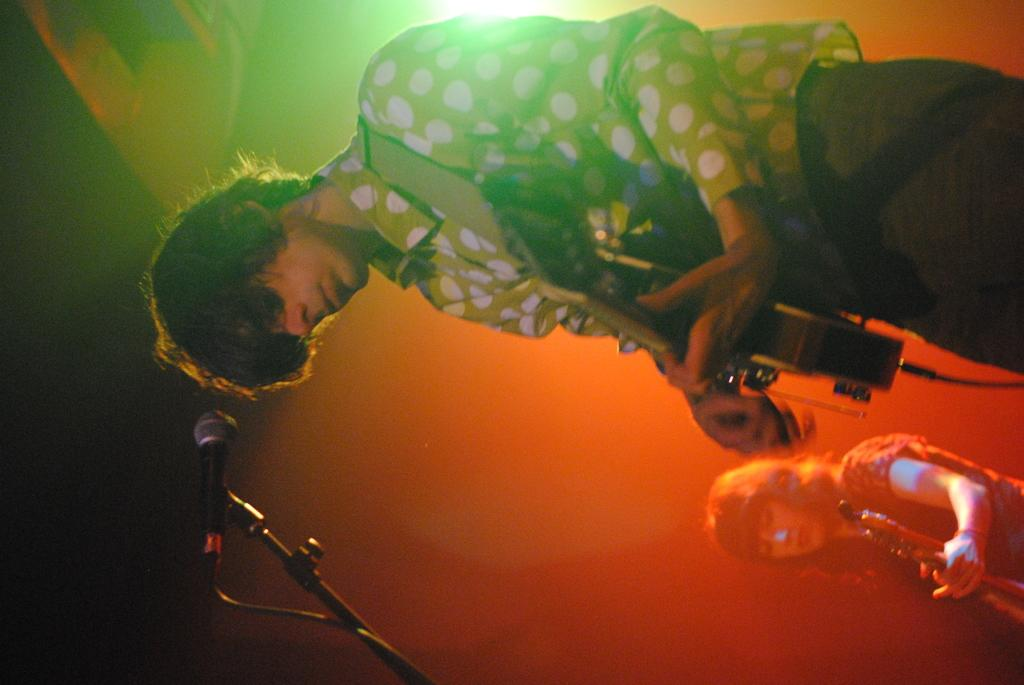How many people are present in the image? There are two people in the image. What are the people doing in the image? The people are playing musical instruments. What equipment is visible in the image that is related to sound? There is a microphone and a mic stand in the image. What type of meal is being prepared in the image? There is no meal preparation visible in the image; it features two people playing musical instruments. Where is the cellar located in the image? There is no cellar present in the image. 